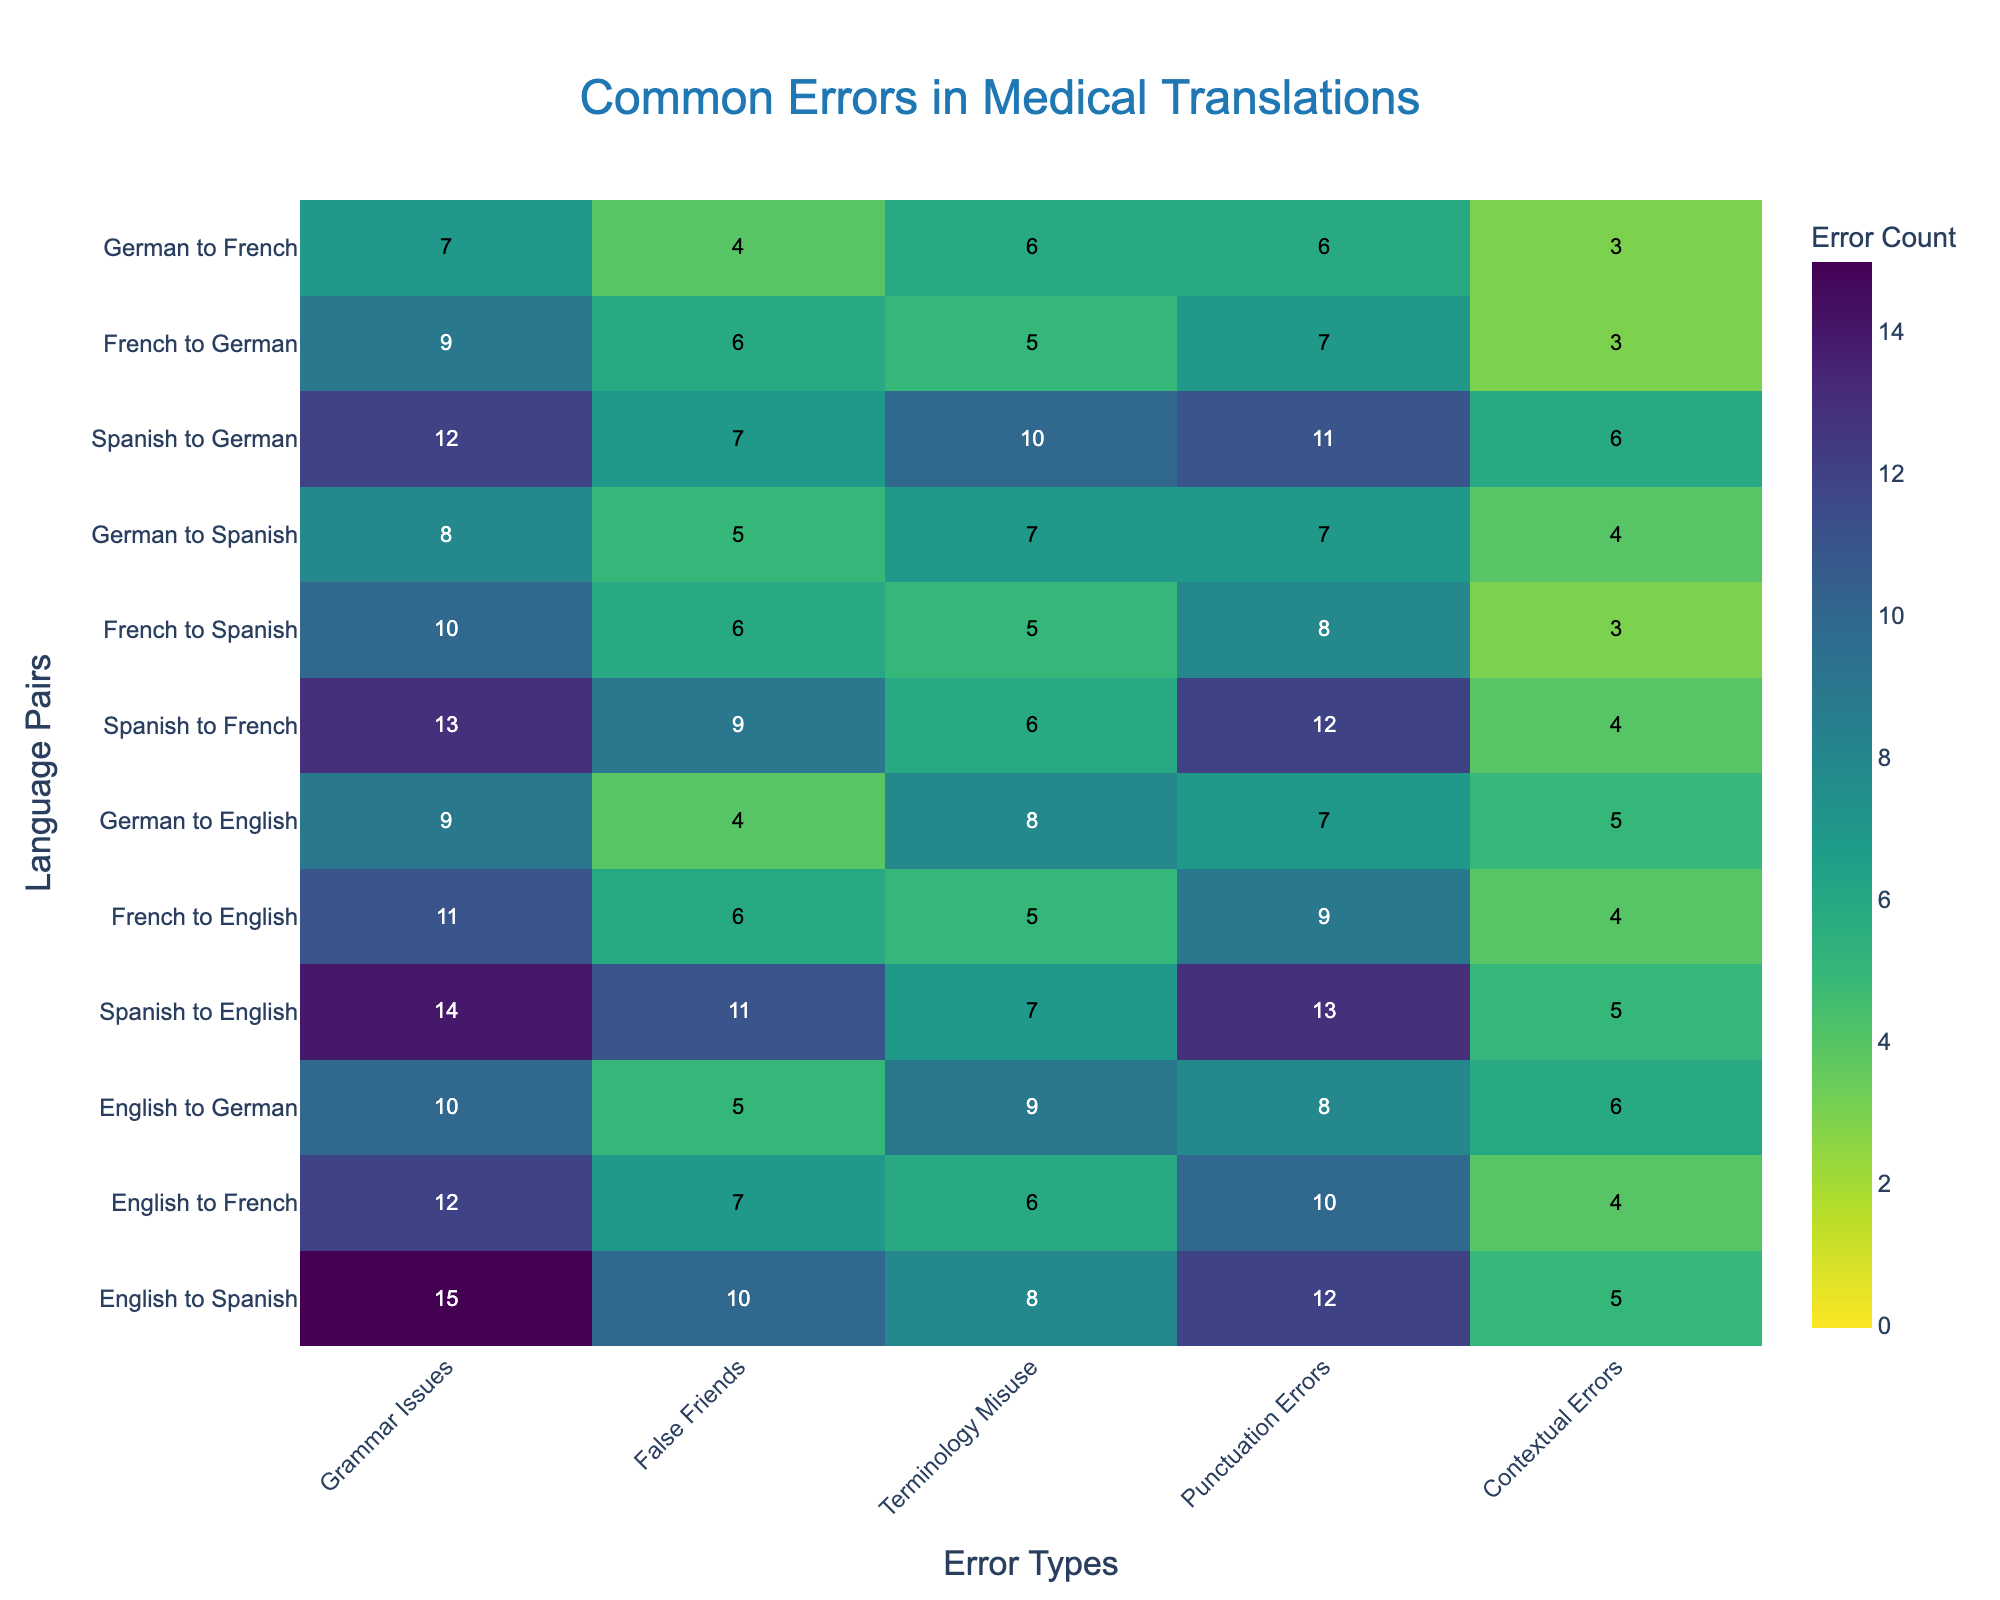How many different types of errors are tracked in the heatmap? The heatmap tracks five different types of errors: Grammar Issues, False Friends, Terminology Misuse, Punctuation Errors, and Contextual Errors. This can be seen from the labels on the x-axis.
Answer: 5 Which language pair has the highest number of grammar issues? By looking at the row for Grammar Issues, we can find the highest value which is 15, corresponding to "English to Spanish".
Answer: English to Spanish What is the total number of terminology misuse errors for the language pairs starting with Spanish? To find this, sum the values for Spanish-English, Spanish-French, and Spanish-German in the terminology misuse column: 7 + 6 + 10 = 23.
Answer: 23 Which language pair has fewer false friends errors: French to German, or German to French? By comparing the false friends errors for both pairs, we see French to German has 6 errors, while German to French has 4 errors. So, German to French has fewer false friends errors.
Answer: German to French What is the average number of contextual errors across all language pairs? To find this, sum all the values for contextual errors (5 + 4 + 6 + 5 + 4 + 5 + 4 + 3 + 4 + 6 + 3 + 3 = 52) and divide by the number of language pairs (12), resulting in 52 / 12 ≈ 4.33.
Answer: 4.33 Between "English to French" and "German to English", which has a higher number of punctuation errors and by how much? Punctuation errors for "English to French" is 10, while for "German to English" it is 7; thus, "English to French" has 3 more punctuation errors.
Answer: English to French by 3 Which error type shows the lowest count for "Spanish to German"? By checking the row for "Spanish to German" across all error types, the lowest value is 7 for False Friends.
Answer: False Friends How many language pairs show a grammar issue count greater than 10? To find this, count the language pairs with grammar issues greater than 10: English-Spanish (15), Spanish-English (14), Spanish-French (13), and Spanish-German (12). Total count is 4.
Answer: 4 What is the sum of punctuation errors for all language pairs involving German as the target language? Sum the values for German as the target: English-German (8), Spanish-German (11), French-German (7). Total is 8 + 11 + 7 = 26.
Answer: 26 Which language pair has the highest variability in error counts and what is the value of this variability? Variability can be approximated by calculating the range (max - min) for each pair. For instance, for English to Spanish: max(15, 10, 8, 12, 5) - min(15, 10, 8, 12, 5) = 15 - 5 = 10. Repeating this for all pairs, English to Spanish has the highest range value of 10.
Answer: English to Spanish with a variability of 10 